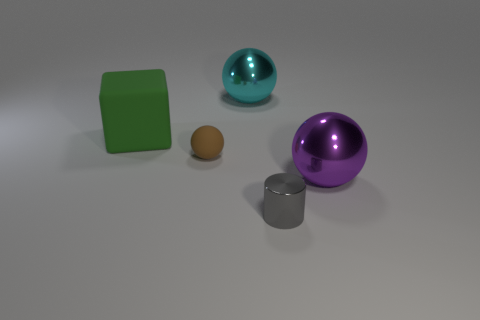Does the big cyan thing have the same shape as the small brown rubber object? yes 